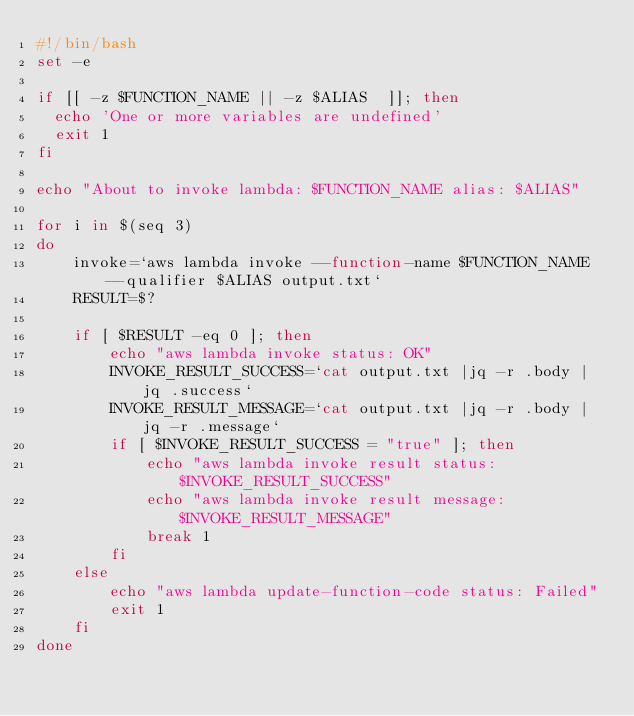Convert code to text. <code><loc_0><loc_0><loc_500><loc_500><_Bash_>#!/bin/bash
set -e

if [[ -z $FUNCTION_NAME || -z $ALIAS  ]]; then
  echo 'One or more variables are undefined'
  exit 1
fi

echo "About to invoke lambda: $FUNCTION_NAME alias: $ALIAS"

for i in $(seq 3)
do
    invoke=`aws lambda invoke --function-name $FUNCTION_NAME --qualifier $ALIAS output.txt`
    RESULT=$?

    if [ $RESULT -eq 0 ]; then
        echo "aws lambda invoke status: OK"
        INVOKE_RESULT_SUCCESS=`cat output.txt |jq -r .body | jq .success`
        INVOKE_RESULT_MESSAGE=`cat output.txt |jq -r .body | jq -r .message`
        if [ $INVOKE_RESULT_SUCCESS = "true" ]; then
            echo "aws lambda invoke result status: $INVOKE_RESULT_SUCCESS"
            echo "aws lambda invoke result message: $INVOKE_RESULT_MESSAGE"
            break 1
        fi
    else
        echo "aws lambda update-function-code status: Failed"
        exit 1
    fi
done
</code> 